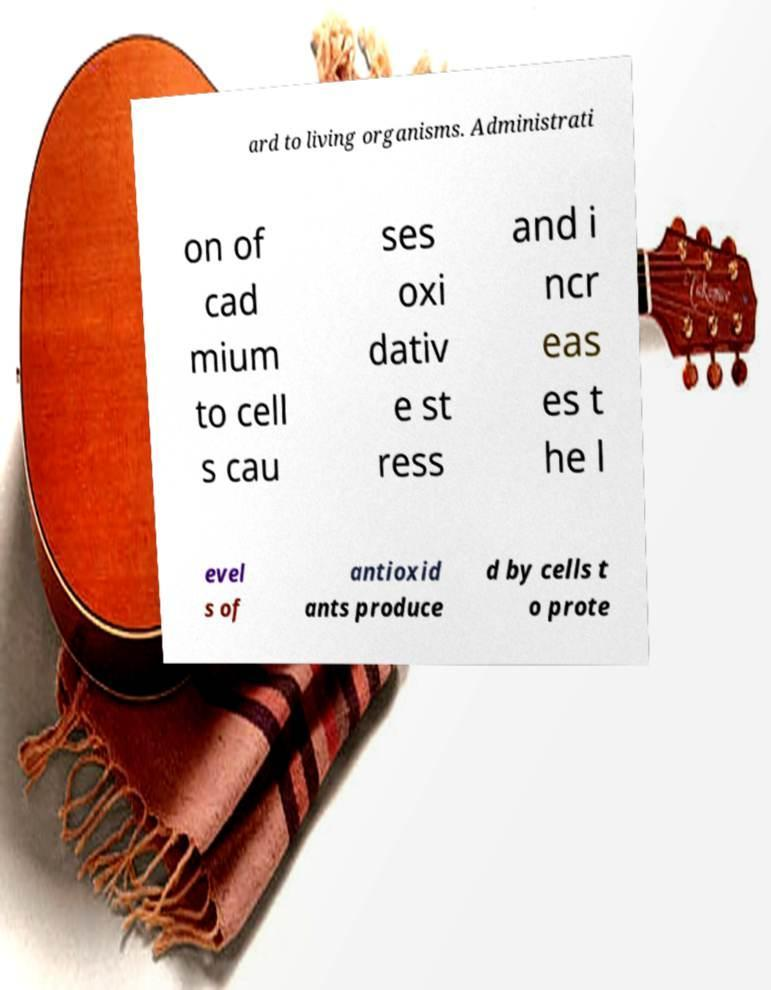Can you read and provide the text displayed in the image?This photo seems to have some interesting text. Can you extract and type it out for me? ard to living organisms. Administrati on of cad mium to cell s cau ses oxi dativ e st ress and i ncr eas es t he l evel s of antioxid ants produce d by cells t o prote 